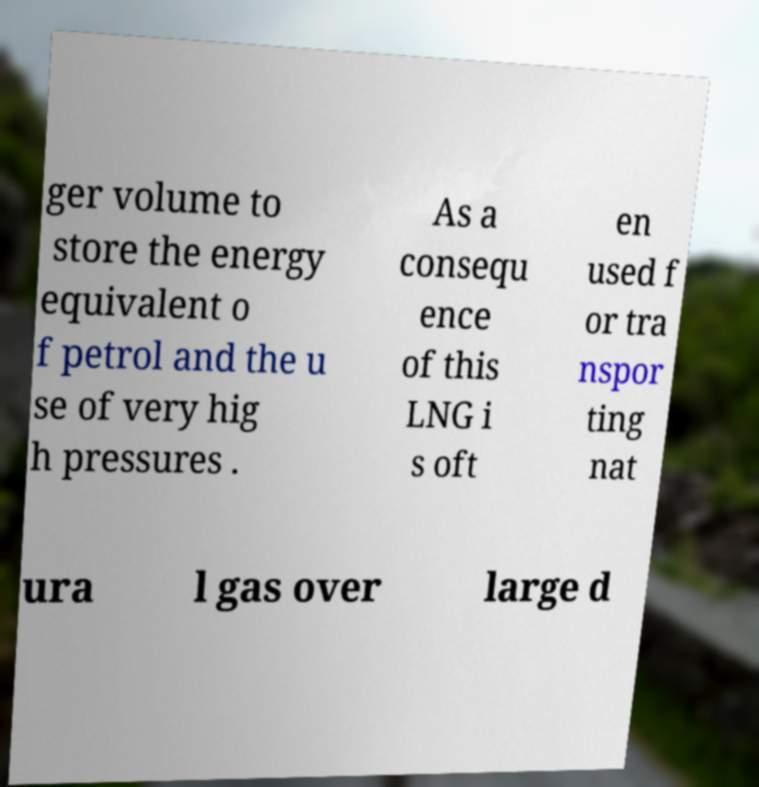Can you read and provide the text displayed in the image?This photo seems to have some interesting text. Can you extract and type it out for me? ger volume to store the energy equivalent o f petrol and the u se of very hig h pressures . As a consequ ence of this LNG i s oft en used f or tra nspor ting nat ura l gas over large d 